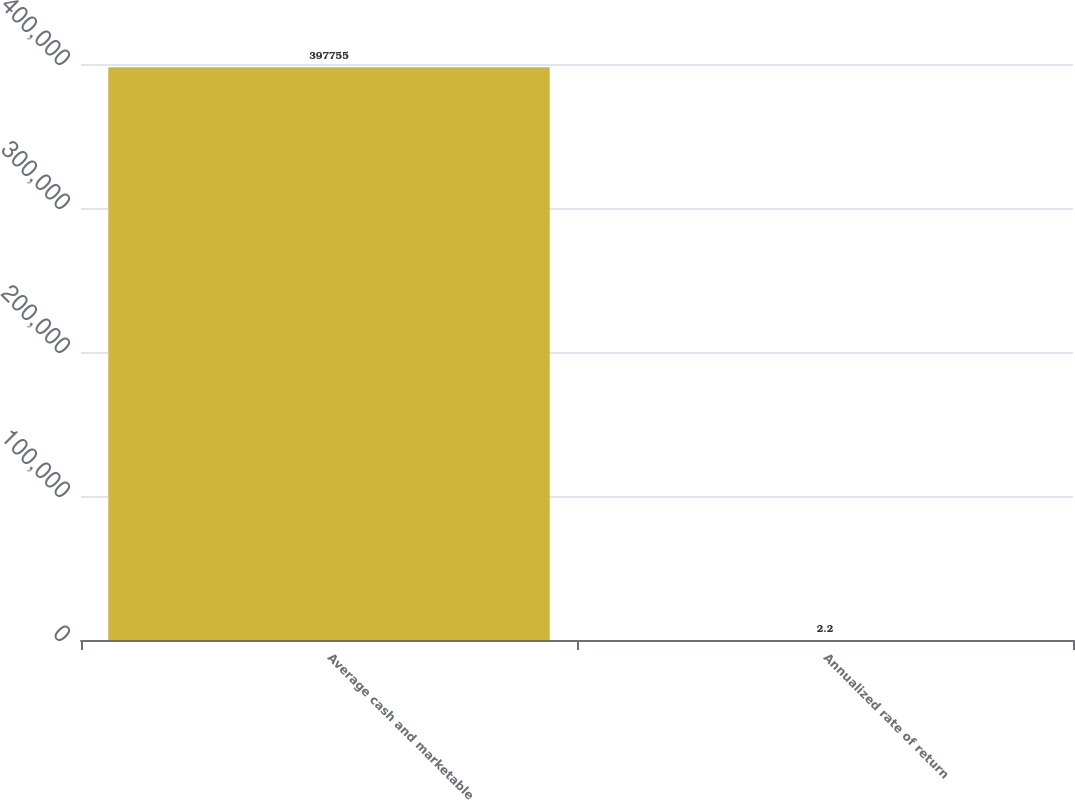Convert chart to OTSL. <chart><loc_0><loc_0><loc_500><loc_500><bar_chart><fcel>Average cash and marketable<fcel>Annualized rate of return<nl><fcel>397755<fcel>2.2<nl></chart> 